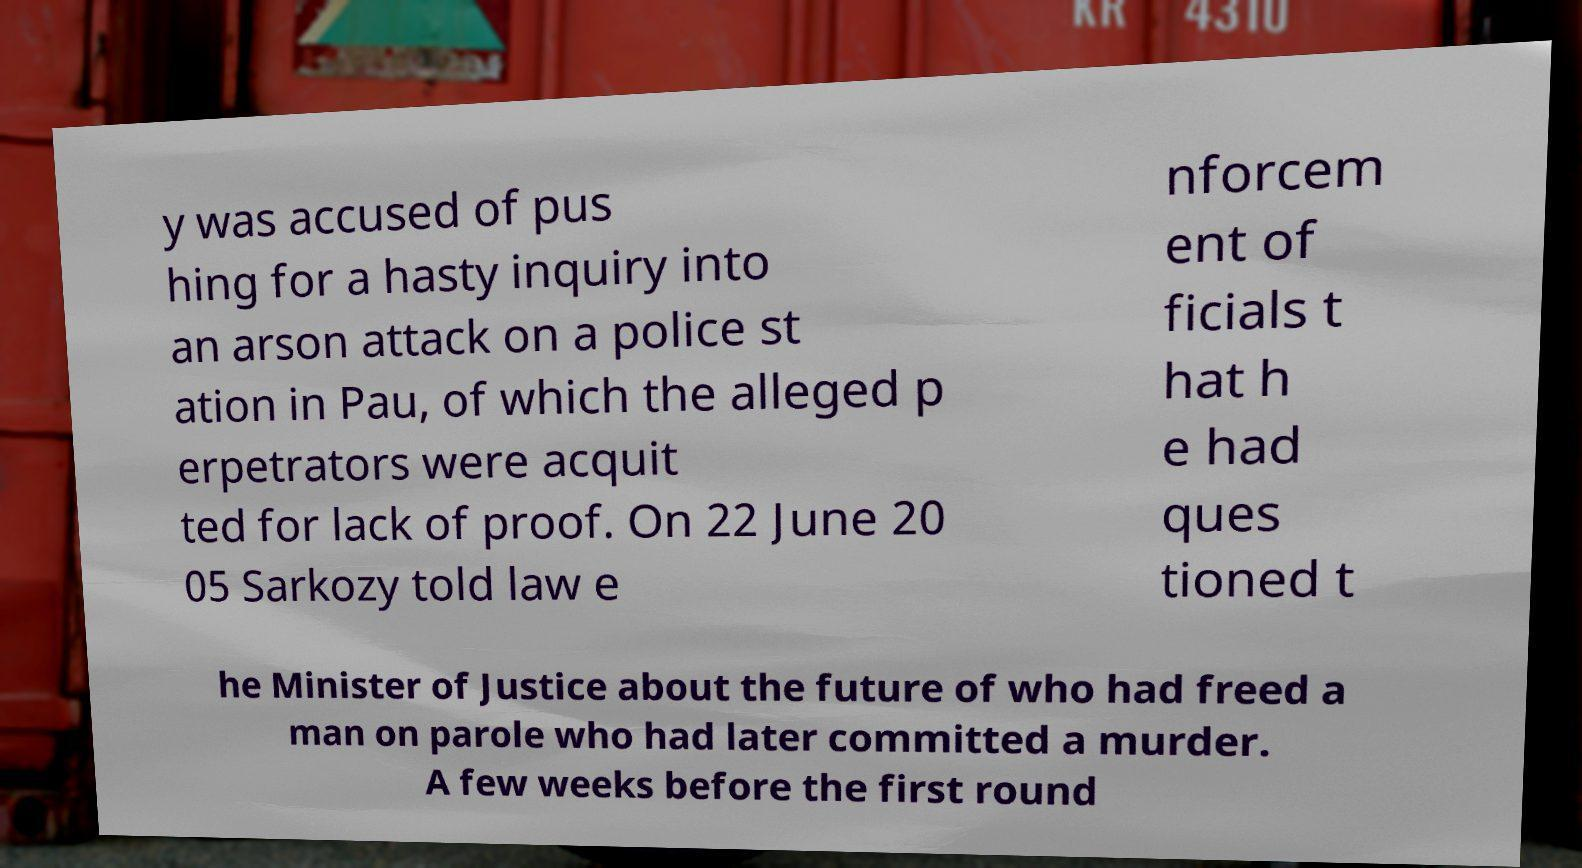Can you accurately transcribe the text from the provided image for me? y was accused of pus hing for a hasty inquiry into an arson attack on a police st ation in Pau, of which the alleged p erpetrators were acquit ted for lack of proof. On 22 June 20 05 Sarkozy told law e nforcem ent of ficials t hat h e had ques tioned t he Minister of Justice about the future of who had freed a man on parole who had later committed a murder. A few weeks before the first round 